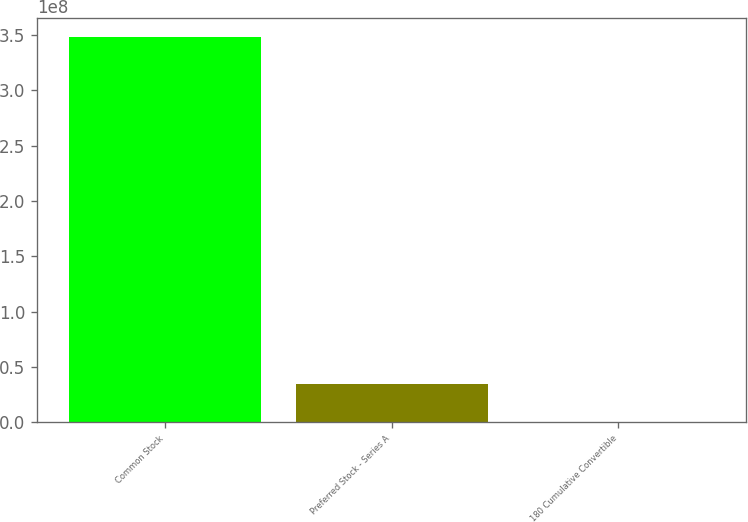Convert chart. <chart><loc_0><loc_0><loc_500><loc_500><bar_chart><fcel>Common Stock<fcel>Preferred Stock - Series A<fcel>180 Cumulative Convertible<nl><fcel>3.4796e+08<fcel>3.48042e+07<fcel>9096<nl></chart> 